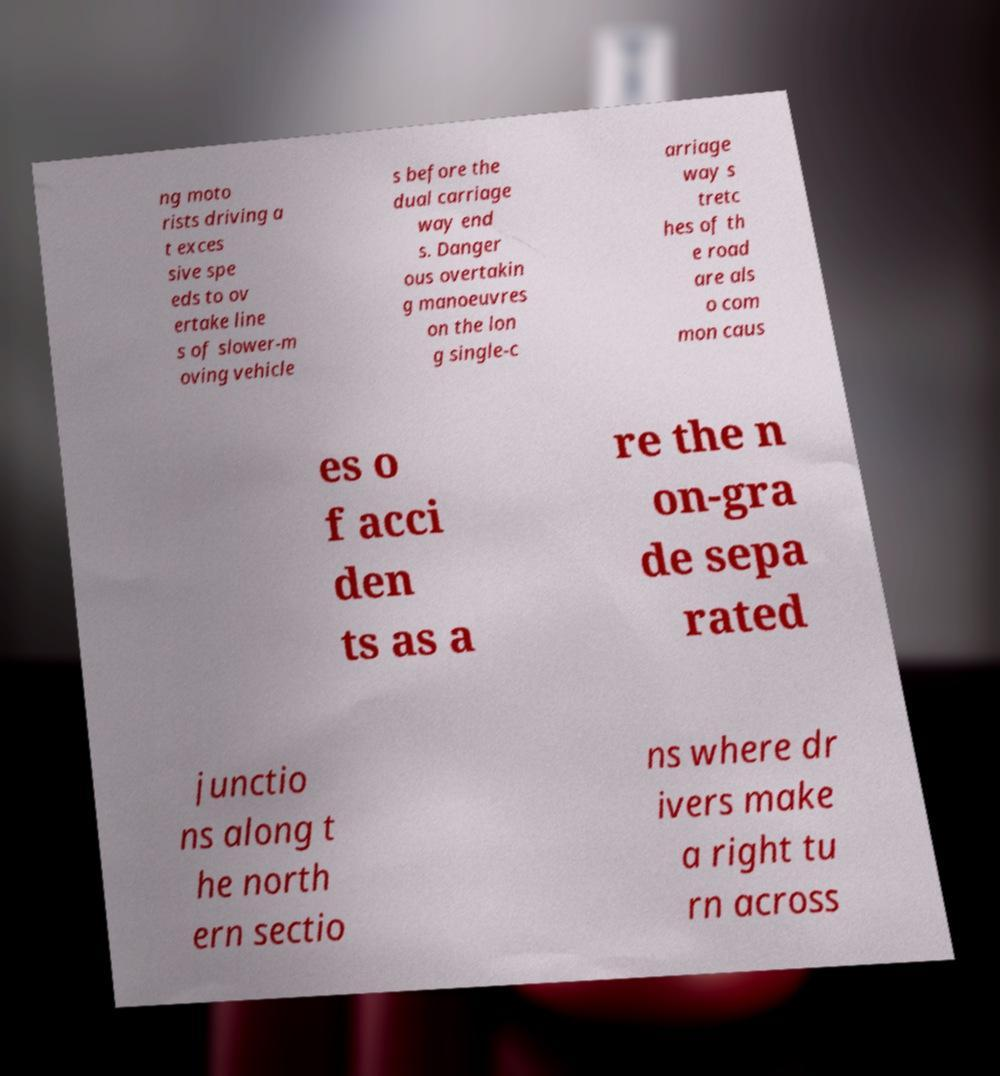What messages or text are displayed in this image? I need them in a readable, typed format. ng moto rists driving a t exces sive spe eds to ov ertake line s of slower-m oving vehicle s before the dual carriage way end s. Danger ous overtakin g manoeuvres on the lon g single-c arriage way s tretc hes of th e road are als o com mon caus es o f acci den ts as a re the n on-gra de sepa rated junctio ns along t he north ern sectio ns where dr ivers make a right tu rn across 